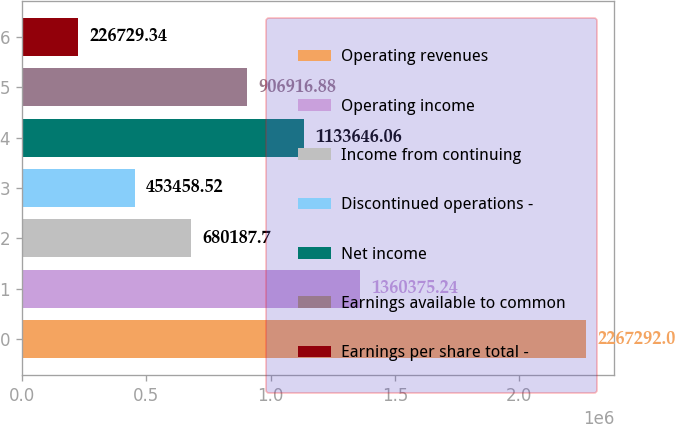Convert chart. <chart><loc_0><loc_0><loc_500><loc_500><bar_chart><fcel>Operating revenues<fcel>Operating income<fcel>Income from continuing<fcel>Discontinued operations -<fcel>Net income<fcel>Earnings available to common<fcel>Earnings per share total -<nl><fcel>2.26729e+06<fcel>1.36038e+06<fcel>680188<fcel>453459<fcel>1.13365e+06<fcel>906917<fcel>226729<nl></chart> 